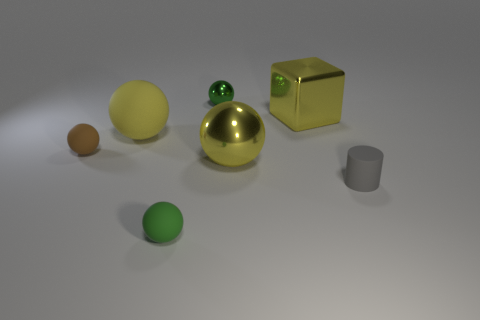What number of other objects are the same material as the tiny gray object?
Provide a succinct answer. 3. Are there fewer tiny balls than large cubes?
Keep it short and to the point. No. Are the small gray cylinder and the large object that is in front of the tiny brown rubber sphere made of the same material?
Your response must be concise. No. What is the shape of the tiny rubber object right of the green shiny sphere?
Ensure brevity in your answer.  Cylinder. Is there anything else that has the same color as the small metallic object?
Your answer should be very brief. Yes. Are there fewer small gray things to the left of the small shiny ball than large yellow cubes?
Your answer should be very brief. Yes. How many blocks are the same size as the green rubber sphere?
Your answer should be very brief. 0. The shiny thing that is the same color as the big shiny sphere is what shape?
Provide a short and direct response. Cube. There is a large yellow thing that is in front of the tiny matte ball that is behind the tiny matte thing in front of the matte cylinder; what is its shape?
Offer a very short reply. Sphere. There is a tiny sphere in front of the tiny gray matte cylinder; what is its color?
Keep it short and to the point. Green. 